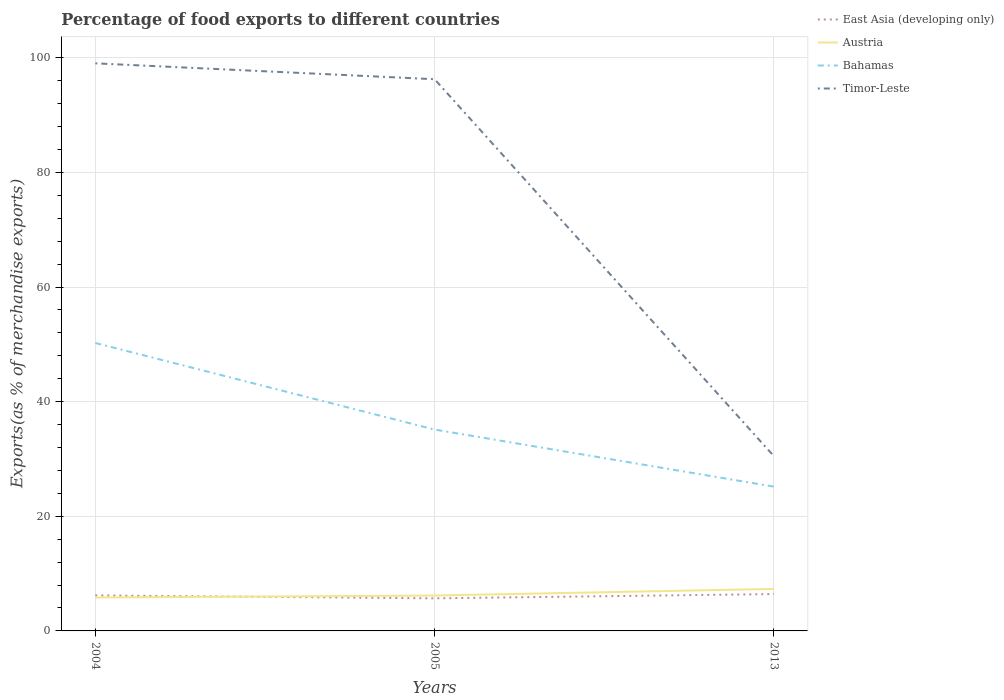Across all years, what is the maximum percentage of exports to different countries in Bahamas?
Your answer should be very brief. 25.17. In which year was the percentage of exports to different countries in Bahamas maximum?
Offer a terse response. 2013. What is the total percentage of exports to different countries in Bahamas in the graph?
Offer a terse response. 25.07. What is the difference between the highest and the second highest percentage of exports to different countries in Austria?
Offer a very short reply. 1.5. What is the difference between the highest and the lowest percentage of exports to different countries in East Asia (developing only)?
Your answer should be very brief. 2. What is the difference between two consecutive major ticks on the Y-axis?
Your response must be concise. 20. Does the graph contain grids?
Your answer should be compact. Yes. What is the title of the graph?
Make the answer very short. Percentage of food exports to different countries. What is the label or title of the Y-axis?
Give a very brief answer. Exports(as % of merchandise exports). What is the Exports(as % of merchandise exports) in East Asia (developing only) in 2004?
Give a very brief answer. 6.2. What is the Exports(as % of merchandise exports) in Austria in 2004?
Your answer should be very brief. 5.83. What is the Exports(as % of merchandise exports) of Bahamas in 2004?
Give a very brief answer. 50.24. What is the Exports(as % of merchandise exports) in Timor-Leste in 2004?
Ensure brevity in your answer.  99.03. What is the Exports(as % of merchandise exports) in East Asia (developing only) in 2005?
Ensure brevity in your answer.  5.69. What is the Exports(as % of merchandise exports) in Austria in 2005?
Your response must be concise. 6.18. What is the Exports(as % of merchandise exports) of Bahamas in 2005?
Provide a succinct answer. 35.13. What is the Exports(as % of merchandise exports) of Timor-Leste in 2005?
Provide a short and direct response. 96.25. What is the Exports(as % of merchandise exports) of East Asia (developing only) in 2013?
Offer a terse response. 6.43. What is the Exports(as % of merchandise exports) in Austria in 2013?
Make the answer very short. 7.33. What is the Exports(as % of merchandise exports) of Bahamas in 2013?
Your answer should be compact. 25.17. What is the Exports(as % of merchandise exports) of Timor-Leste in 2013?
Your answer should be very brief. 30.49. Across all years, what is the maximum Exports(as % of merchandise exports) of East Asia (developing only)?
Keep it short and to the point. 6.43. Across all years, what is the maximum Exports(as % of merchandise exports) of Austria?
Your response must be concise. 7.33. Across all years, what is the maximum Exports(as % of merchandise exports) of Bahamas?
Your answer should be very brief. 50.24. Across all years, what is the maximum Exports(as % of merchandise exports) of Timor-Leste?
Your answer should be compact. 99.03. Across all years, what is the minimum Exports(as % of merchandise exports) of East Asia (developing only)?
Your answer should be very brief. 5.69. Across all years, what is the minimum Exports(as % of merchandise exports) of Austria?
Your answer should be very brief. 5.83. Across all years, what is the minimum Exports(as % of merchandise exports) of Bahamas?
Your answer should be compact. 25.17. Across all years, what is the minimum Exports(as % of merchandise exports) of Timor-Leste?
Provide a succinct answer. 30.49. What is the total Exports(as % of merchandise exports) in East Asia (developing only) in the graph?
Keep it short and to the point. 18.32. What is the total Exports(as % of merchandise exports) of Austria in the graph?
Your answer should be compact. 19.34. What is the total Exports(as % of merchandise exports) in Bahamas in the graph?
Your response must be concise. 110.54. What is the total Exports(as % of merchandise exports) of Timor-Leste in the graph?
Keep it short and to the point. 225.78. What is the difference between the Exports(as % of merchandise exports) in East Asia (developing only) in 2004 and that in 2005?
Keep it short and to the point. 0.51. What is the difference between the Exports(as % of merchandise exports) of Austria in 2004 and that in 2005?
Offer a terse response. -0.34. What is the difference between the Exports(as % of merchandise exports) of Bahamas in 2004 and that in 2005?
Provide a succinct answer. 15.11. What is the difference between the Exports(as % of merchandise exports) in Timor-Leste in 2004 and that in 2005?
Keep it short and to the point. 2.78. What is the difference between the Exports(as % of merchandise exports) in East Asia (developing only) in 2004 and that in 2013?
Keep it short and to the point. -0.23. What is the difference between the Exports(as % of merchandise exports) of Austria in 2004 and that in 2013?
Keep it short and to the point. -1.5. What is the difference between the Exports(as % of merchandise exports) of Bahamas in 2004 and that in 2013?
Provide a short and direct response. 25.07. What is the difference between the Exports(as % of merchandise exports) in Timor-Leste in 2004 and that in 2013?
Offer a terse response. 68.54. What is the difference between the Exports(as % of merchandise exports) of East Asia (developing only) in 2005 and that in 2013?
Your response must be concise. -0.74. What is the difference between the Exports(as % of merchandise exports) of Austria in 2005 and that in 2013?
Offer a very short reply. -1.15. What is the difference between the Exports(as % of merchandise exports) of Bahamas in 2005 and that in 2013?
Offer a terse response. 9.96. What is the difference between the Exports(as % of merchandise exports) of Timor-Leste in 2005 and that in 2013?
Make the answer very short. 65.76. What is the difference between the Exports(as % of merchandise exports) in East Asia (developing only) in 2004 and the Exports(as % of merchandise exports) in Austria in 2005?
Offer a very short reply. 0.02. What is the difference between the Exports(as % of merchandise exports) of East Asia (developing only) in 2004 and the Exports(as % of merchandise exports) of Bahamas in 2005?
Provide a succinct answer. -28.93. What is the difference between the Exports(as % of merchandise exports) in East Asia (developing only) in 2004 and the Exports(as % of merchandise exports) in Timor-Leste in 2005?
Make the answer very short. -90.06. What is the difference between the Exports(as % of merchandise exports) in Austria in 2004 and the Exports(as % of merchandise exports) in Bahamas in 2005?
Your answer should be compact. -29.3. What is the difference between the Exports(as % of merchandise exports) in Austria in 2004 and the Exports(as % of merchandise exports) in Timor-Leste in 2005?
Ensure brevity in your answer.  -90.42. What is the difference between the Exports(as % of merchandise exports) of Bahamas in 2004 and the Exports(as % of merchandise exports) of Timor-Leste in 2005?
Offer a very short reply. -46.02. What is the difference between the Exports(as % of merchandise exports) of East Asia (developing only) in 2004 and the Exports(as % of merchandise exports) of Austria in 2013?
Your answer should be compact. -1.13. What is the difference between the Exports(as % of merchandise exports) in East Asia (developing only) in 2004 and the Exports(as % of merchandise exports) in Bahamas in 2013?
Provide a succinct answer. -18.97. What is the difference between the Exports(as % of merchandise exports) of East Asia (developing only) in 2004 and the Exports(as % of merchandise exports) of Timor-Leste in 2013?
Your answer should be compact. -24.29. What is the difference between the Exports(as % of merchandise exports) in Austria in 2004 and the Exports(as % of merchandise exports) in Bahamas in 2013?
Your answer should be very brief. -19.34. What is the difference between the Exports(as % of merchandise exports) of Austria in 2004 and the Exports(as % of merchandise exports) of Timor-Leste in 2013?
Your answer should be very brief. -24.66. What is the difference between the Exports(as % of merchandise exports) of Bahamas in 2004 and the Exports(as % of merchandise exports) of Timor-Leste in 2013?
Provide a short and direct response. 19.75. What is the difference between the Exports(as % of merchandise exports) of East Asia (developing only) in 2005 and the Exports(as % of merchandise exports) of Austria in 2013?
Give a very brief answer. -1.64. What is the difference between the Exports(as % of merchandise exports) of East Asia (developing only) in 2005 and the Exports(as % of merchandise exports) of Bahamas in 2013?
Make the answer very short. -19.49. What is the difference between the Exports(as % of merchandise exports) of East Asia (developing only) in 2005 and the Exports(as % of merchandise exports) of Timor-Leste in 2013?
Give a very brief answer. -24.81. What is the difference between the Exports(as % of merchandise exports) of Austria in 2005 and the Exports(as % of merchandise exports) of Bahamas in 2013?
Provide a succinct answer. -19. What is the difference between the Exports(as % of merchandise exports) of Austria in 2005 and the Exports(as % of merchandise exports) of Timor-Leste in 2013?
Keep it short and to the point. -24.32. What is the difference between the Exports(as % of merchandise exports) of Bahamas in 2005 and the Exports(as % of merchandise exports) of Timor-Leste in 2013?
Offer a very short reply. 4.64. What is the average Exports(as % of merchandise exports) in East Asia (developing only) per year?
Your response must be concise. 6.11. What is the average Exports(as % of merchandise exports) of Austria per year?
Keep it short and to the point. 6.45. What is the average Exports(as % of merchandise exports) of Bahamas per year?
Your answer should be compact. 36.85. What is the average Exports(as % of merchandise exports) of Timor-Leste per year?
Provide a short and direct response. 75.26. In the year 2004, what is the difference between the Exports(as % of merchandise exports) of East Asia (developing only) and Exports(as % of merchandise exports) of Austria?
Provide a succinct answer. 0.37. In the year 2004, what is the difference between the Exports(as % of merchandise exports) of East Asia (developing only) and Exports(as % of merchandise exports) of Bahamas?
Provide a short and direct response. -44.04. In the year 2004, what is the difference between the Exports(as % of merchandise exports) in East Asia (developing only) and Exports(as % of merchandise exports) in Timor-Leste?
Your answer should be very brief. -92.83. In the year 2004, what is the difference between the Exports(as % of merchandise exports) of Austria and Exports(as % of merchandise exports) of Bahamas?
Offer a terse response. -44.41. In the year 2004, what is the difference between the Exports(as % of merchandise exports) of Austria and Exports(as % of merchandise exports) of Timor-Leste?
Provide a short and direct response. -93.2. In the year 2004, what is the difference between the Exports(as % of merchandise exports) of Bahamas and Exports(as % of merchandise exports) of Timor-Leste?
Offer a very short reply. -48.79. In the year 2005, what is the difference between the Exports(as % of merchandise exports) of East Asia (developing only) and Exports(as % of merchandise exports) of Austria?
Provide a succinct answer. -0.49. In the year 2005, what is the difference between the Exports(as % of merchandise exports) of East Asia (developing only) and Exports(as % of merchandise exports) of Bahamas?
Your answer should be compact. -29.44. In the year 2005, what is the difference between the Exports(as % of merchandise exports) of East Asia (developing only) and Exports(as % of merchandise exports) of Timor-Leste?
Give a very brief answer. -90.57. In the year 2005, what is the difference between the Exports(as % of merchandise exports) of Austria and Exports(as % of merchandise exports) of Bahamas?
Keep it short and to the point. -28.95. In the year 2005, what is the difference between the Exports(as % of merchandise exports) in Austria and Exports(as % of merchandise exports) in Timor-Leste?
Offer a terse response. -90.08. In the year 2005, what is the difference between the Exports(as % of merchandise exports) in Bahamas and Exports(as % of merchandise exports) in Timor-Leste?
Make the answer very short. -61.13. In the year 2013, what is the difference between the Exports(as % of merchandise exports) in East Asia (developing only) and Exports(as % of merchandise exports) in Austria?
Offer a terse response. -0.9. In the year 2013, what is the difference between the Exports(as % of merchandise exports) of East Asia (developing only) and Exports(as % of merchandise exports) of Bahamas?
Keep it short and to the point. -18.74. In the year 2013, what is the difference between the Exports(as % of merchandise exports) of East Asia (developing only) and Exports(as % of merchandise exports) of Timor-Leste?
Your response must be concise. -24.06. In the year 2013, what is the difference between the Exports(as % of merchandise exports) of Austria and Exports(as % of merchandise exports) of Bahamas?
Give a very brief answer. -17.84. In the year 2013, what is the difference between the Exports(as % of merchandise exports) of Austria and Exports(as % of merchandise exports) of Timor-Leste?
Your response must be concise. -23.16. In the year 2013, what is the difference between the Exports(as % of merchandise exports) of Bahamas and Exports(as % of merchandise exports) of Timor-Leste?
Keep it short and to the point. -5.32. What is the ratio of the Exports(as % of merchandise exports) of East Asia (developing only) in 2004 to that in 2005?
Give a very brief answer. 1.09. What is the ratio of the Exports(as % of merchandise exports) of Austria in 2004 to that in 2005?
Your answer should be very brief. 0.94. What is the ratio of the Exports(as % of merchandise exports) of Bahamas in 2004 to that in 2005?
Your answer should be compact. 1.43. What is the ratio of the Exports(as % of merchandise exports) in Timor-Leste in 2004 to that in 2005?
Provide a succinct answer. 1.03. What is the ratio of the Exports(as % of merchandise exports) in East Asia (developing only) in 2004 to that in 2013?
Keep it short and to the point. 0.96. What is the ratio of the Exports(as % of merchandise exports) of Austria in 2004 to that in 2013?
Give a very brief answer. 0.8. What is the ratio of the Exports(as % of merchandise exports) of Bahamas in 2004 to that in 2013?
Ensure brevity in your answer.  2. What is the ratio of the Exports(as % of merchandise exports) of Timor-Leste in 2004 to that in 2013?
Offer a terse response. 3.25. What is the ratio of the Exports(as % of merchandise exports) of East Asia (developing only) in 2005 to that in 2013?
Provide a short and direct response. 0.88. What is the ratio of the Exports(as % of merchandise exports) in Austria in 2005 to that in 2013?
Provide a succinct answer. 0.84. What is the ratio of the Exports(as % of merchandise exports) of Bahamas in 2005 to that in 2013?
Offer a terse response. 1.4. What is the ratio of the Exports(as % of merchandise exports) of Timor-Leste in 2005 to that in 2013?
Give a very brief answer. 3.16. What is the difference between the highest and the second highest Exports(as % of merchandise exports) of East Asia (developing only)?
Offer a terse response. 0.23. What is the difference between the highest and the second highest Exports(as % of merchandise exports) in Austria?
Offer a terse response. 1.15. What is the difference between the highest and the second highest Exports(as % of merchandise exports) in Bahamas?
Give a very brief answer. 15.11. What is the difference between the highest and the second highest Exports(as % of merchandise exports) of Timor-Leste?
Your response must be concise. 2.78. What is the difference between the highest and the lowest Exports(as % of merchandise exports) in East Asia (developing only)?
Your answer should be very brief. 0.74. What is the difference between the highest and the lowest Exports(as % of merchandise exports) in Austria?
Your answer should be compact. 1.5. What is the difference between the highest and the lowest Exports(as % of merchandise exports) in Bahamas?
Offer a very short reply. 25.07. What is the difference between the highest and the lowest Exports(as % of merchandise exports) of Timor-Leste?
Your answer should be very brief. 68.54. 